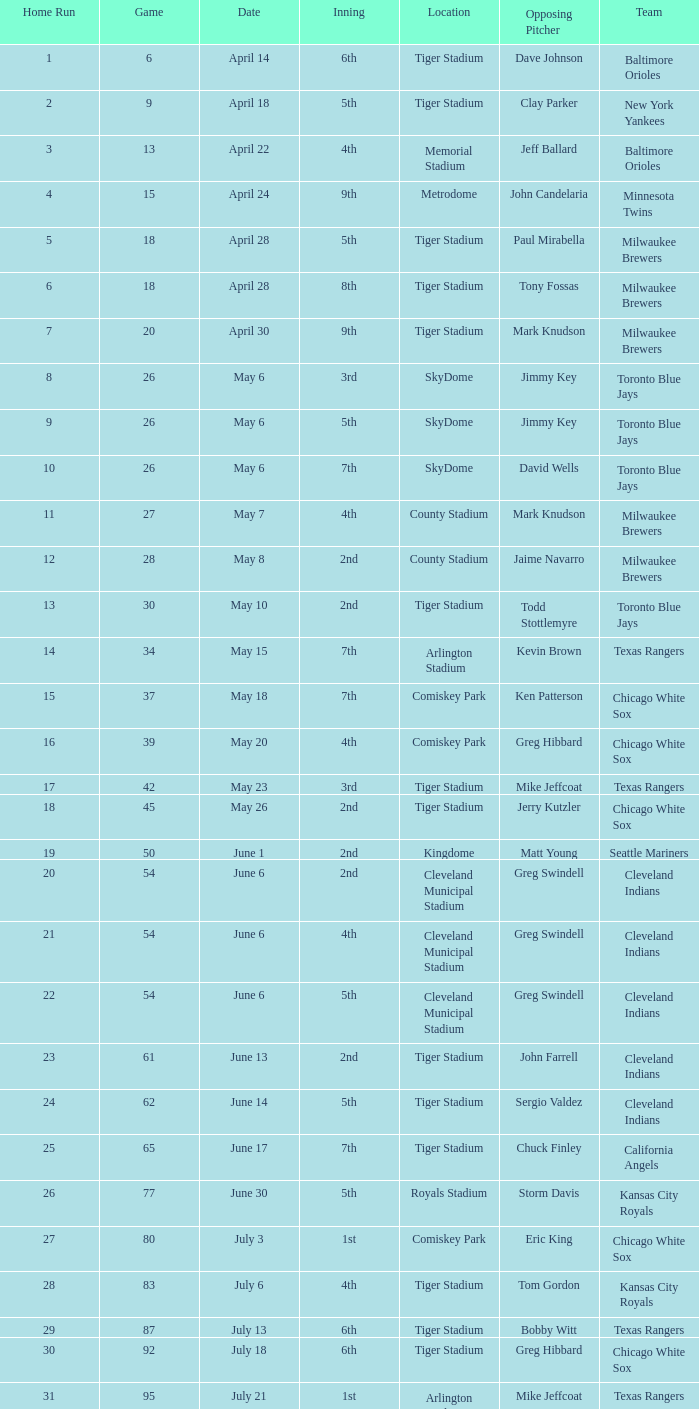What date was the game at Comiskey Park and had a 4th Inning? May 20. 